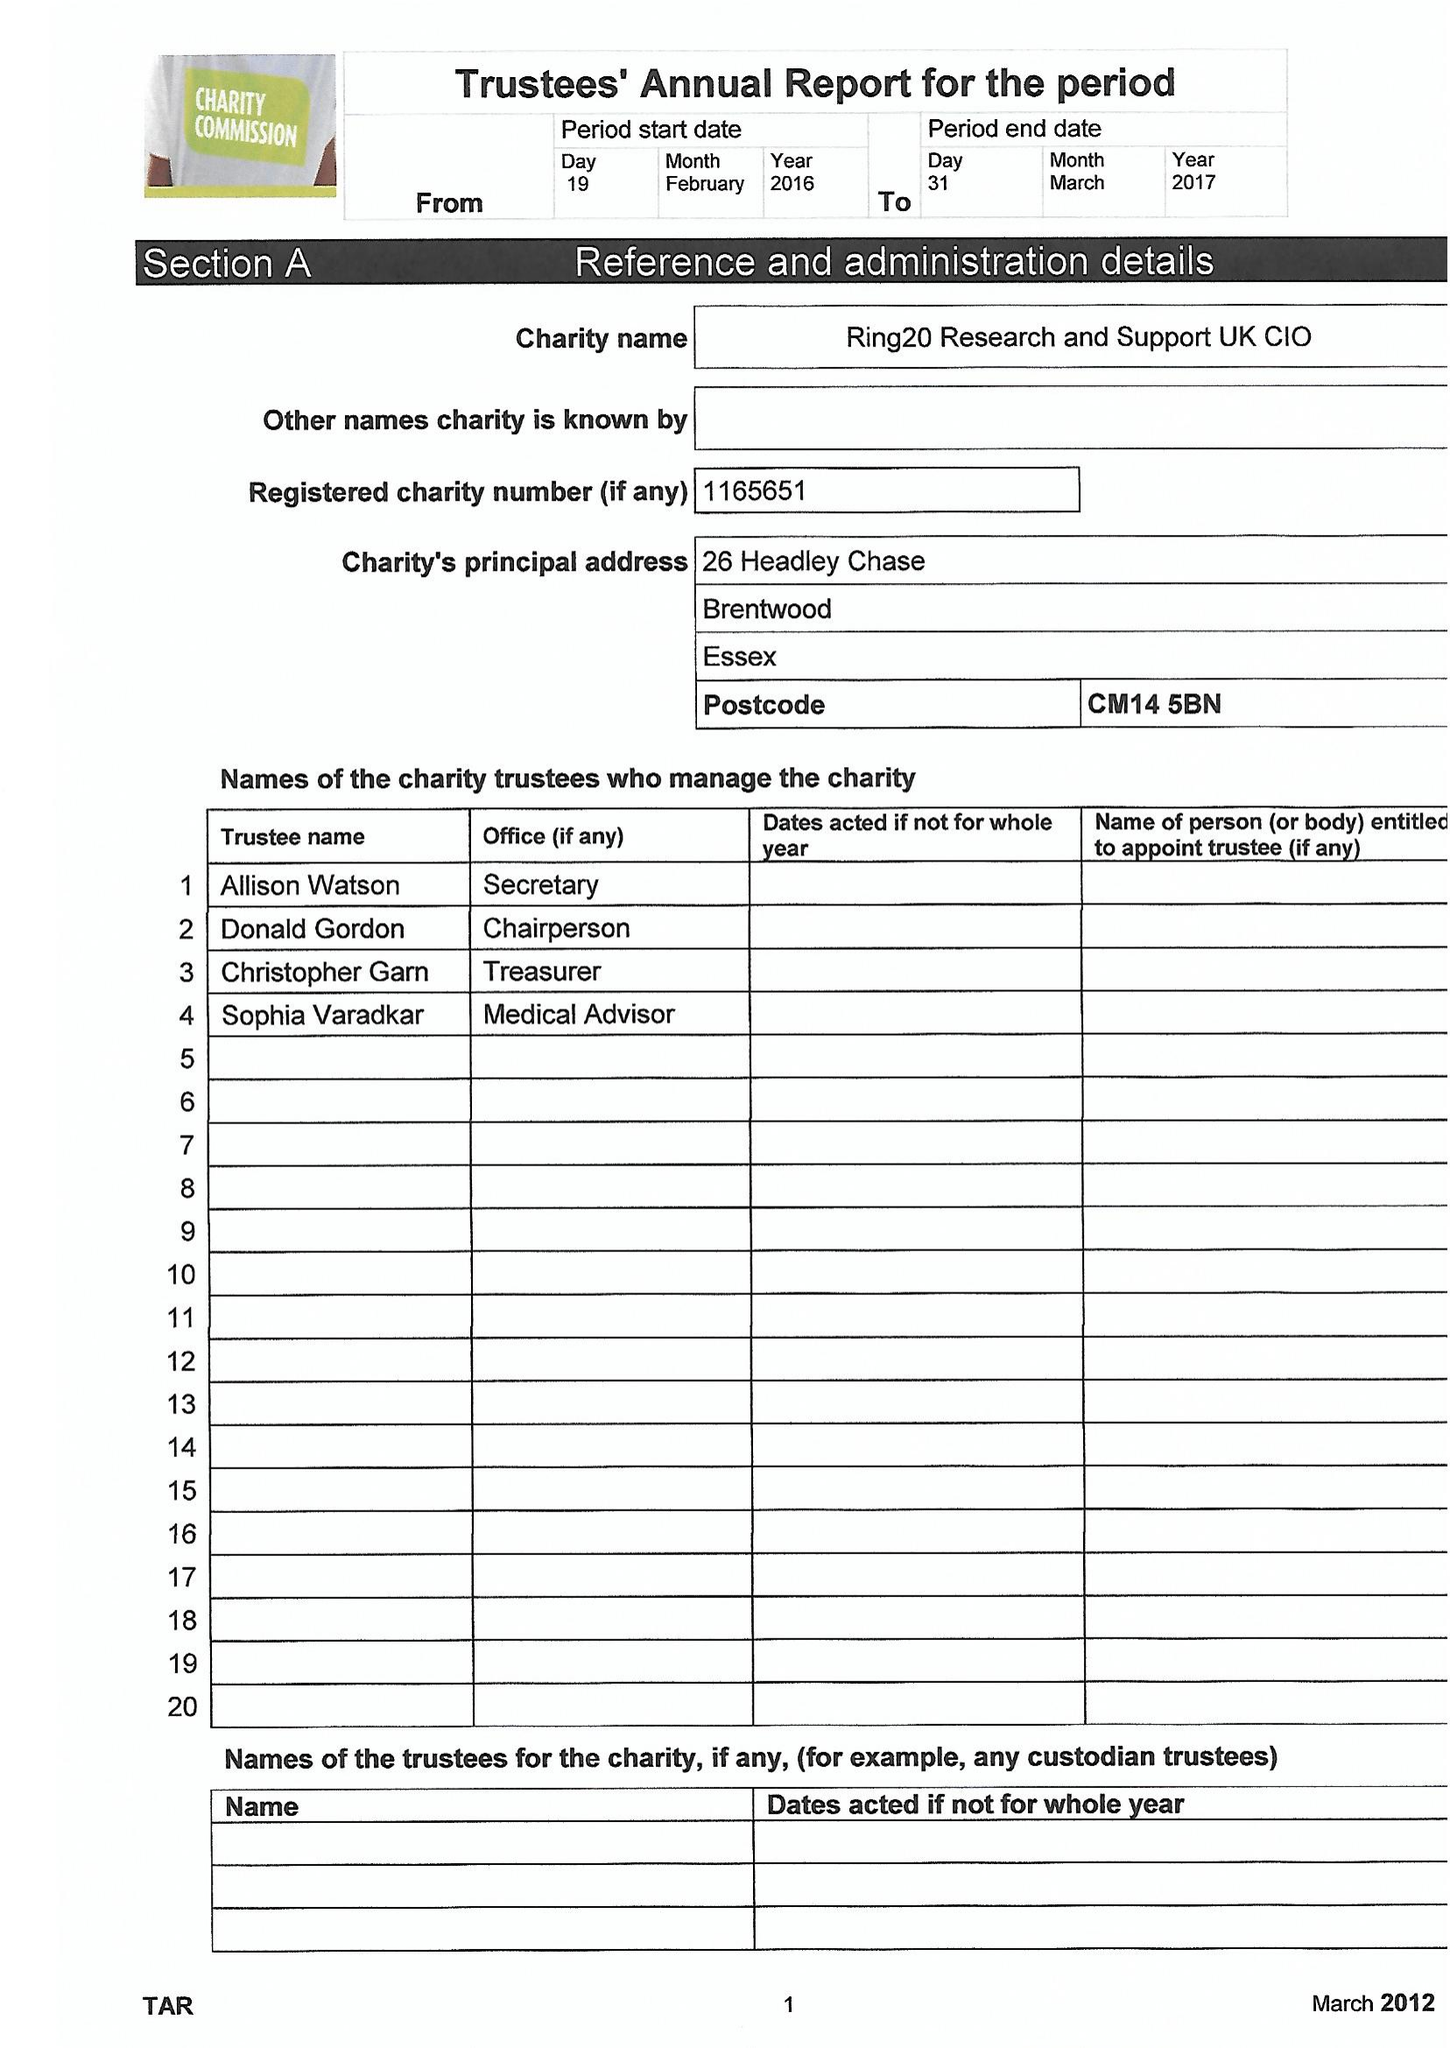What is the value for the report_date?
Answer the question using a single word or phrase. 2017-03-31 